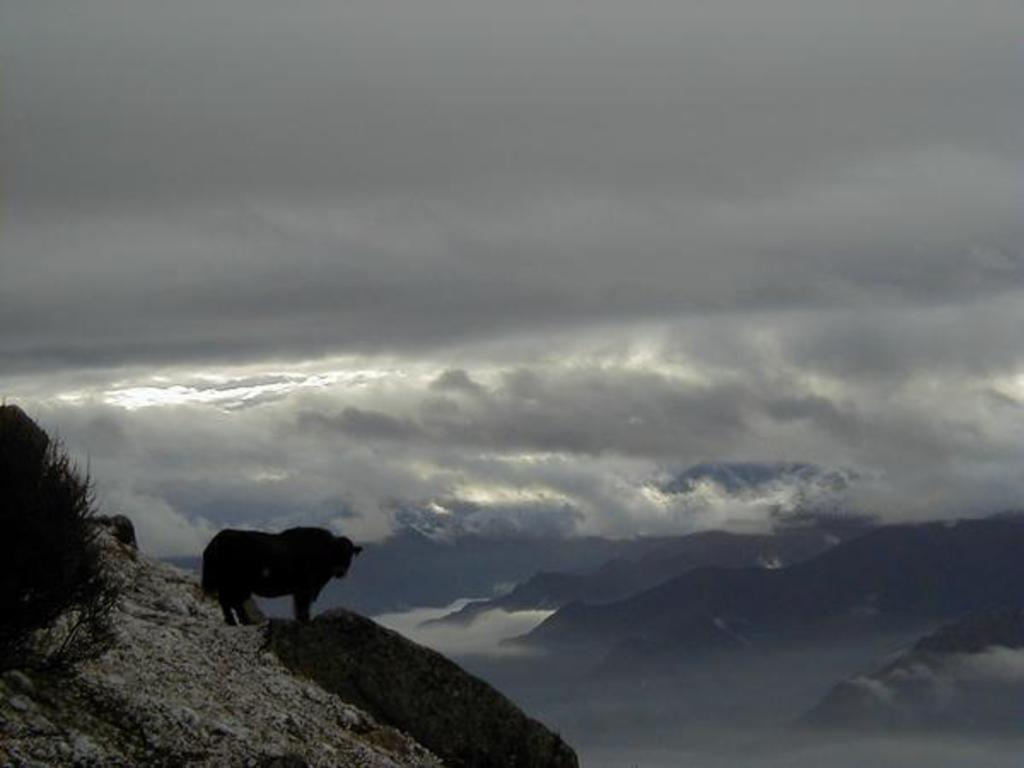What type of animal is on the right side of the image? The animal on the right side of the image is not specified, but it is present. What other living organism can be seen in the image? There is a plant in the image. What geographical feature is at the bottom of the image? There is a mountain at the bottom of the image. What can be seen in the background of the image? There are mountains visible in the background of the image. What is visible at the top of the image? The sky is visible at the top of the image. What type of lunch is being offered to the plant in the image? There is no lunch or food being offered to the plant in the image. What selection of items can be seen in the image? The image contains an animal, a plant, a mountain at the bottom, mountains in the background, and the sky at the top. 